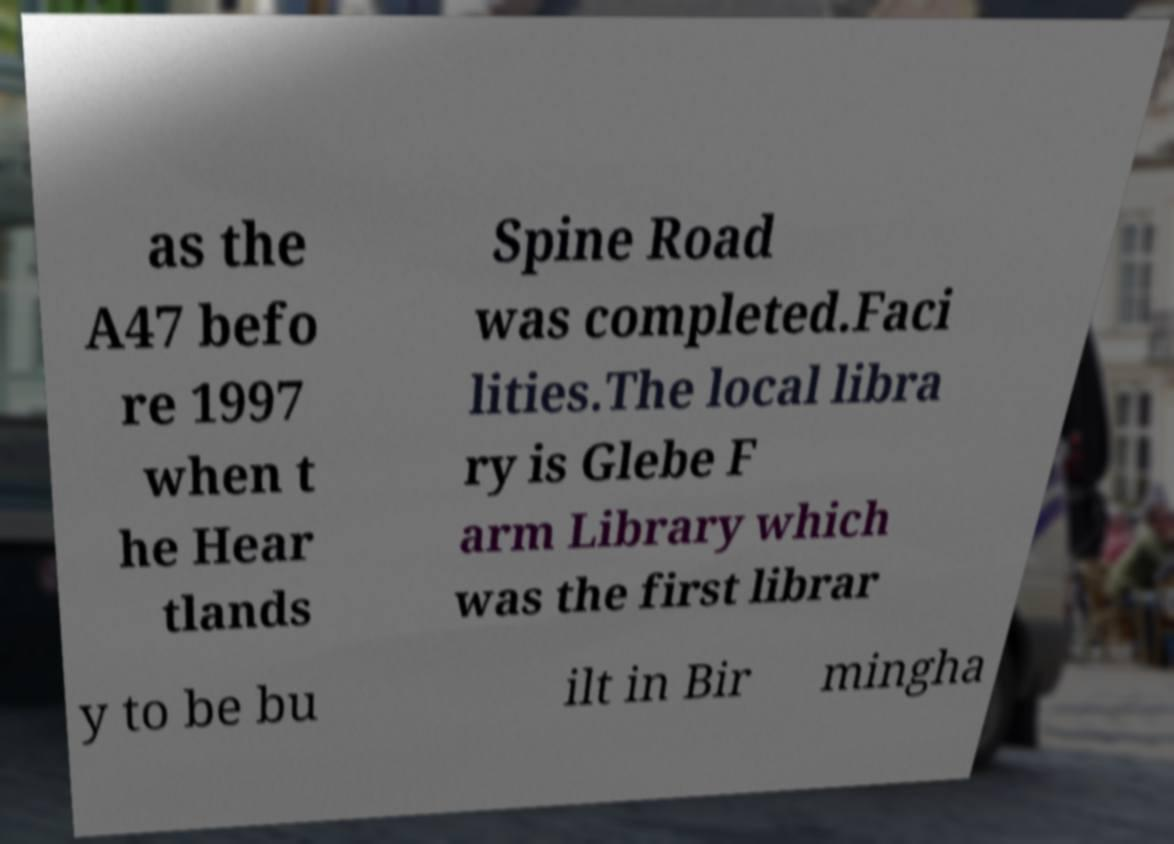Could you extract and type out the text from this image? as the A47 befo re 1997 when t he Hear tlands Spine Road was completed.Faci lities.The local libra ry is Glebe F arm Library which was the first librar y to be bu ilt in Bir mingha 